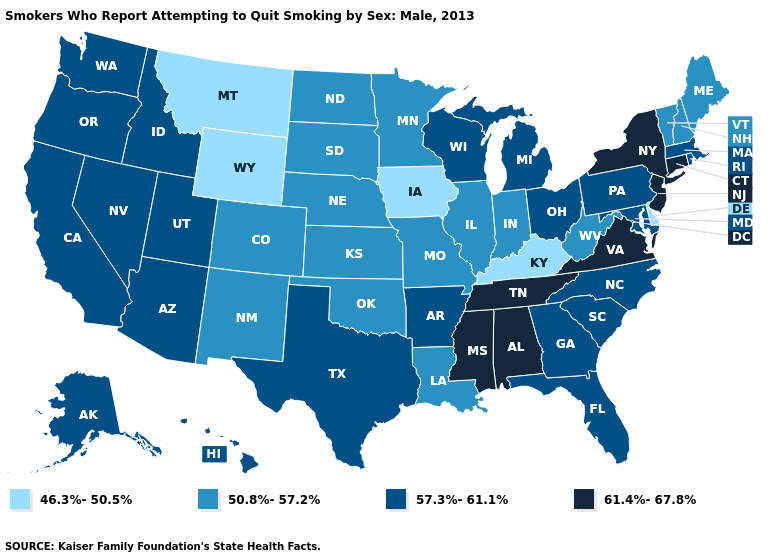Among the states that border Arkansas , which have the lowest value?
Short answer required. Louisiana, Missouri, Oklahoma. Name the states that have a value in the range 46.3%-50.5%?
Be succinct. Delaware, Iowa, Kentucky, Montana, Wyoming. What is the lowest value in states that border Missouri?
Concise answer only. 46.3%-50.5%. Among the states that border Florida , which have the lowest value?
Quick response, please. Georgia. Name the states that have a value in the range 46.3%-50.5%?
Be succinct. Delaware, Iowa, Kentucky, Montana, Wyoming. What is the highest value in states that border New York?
Answer briefly. 61.4%-67.8%. Name the states that have a value in the range 57.3%-61.1%?
Keep it brief. Alaska, Arizona, Arkansas, California, Florida, Georgia, Hawaii, Idaho, Maryland, Massachusetts, Michigan, Nevada, North Carolina, Ohio, Oregon, Pennsylvania, Rhode Island, South Carolina, Texas, Utah, Washington, Wisconsin. What is the lowest value in the MidWest?
Quick response, please. 46.3%-50.5%. Does New Hampshire have the lowest value in the USA?
Short answer required. No. Among the states that border Nebraska , which have the lowest value?
Concise answer only. Iowa, Wyoming. Does Connecticut have the lowest value in the Northeast?
Quick response, please. No. Name the states that have a value in the range 61.4%-67.8%?
Keep it brief. Alabama, Connecticut, Mississippi, New Jersey, New York, Tennessee, Virginia. What is the highest value in the USA?
Answer briefly. 61.4%-67.8%. How many symbols are there in the legend?
Short answer required. 4. What is the value of Mississippi?
Short answer required. 61.4%-67.8%. 